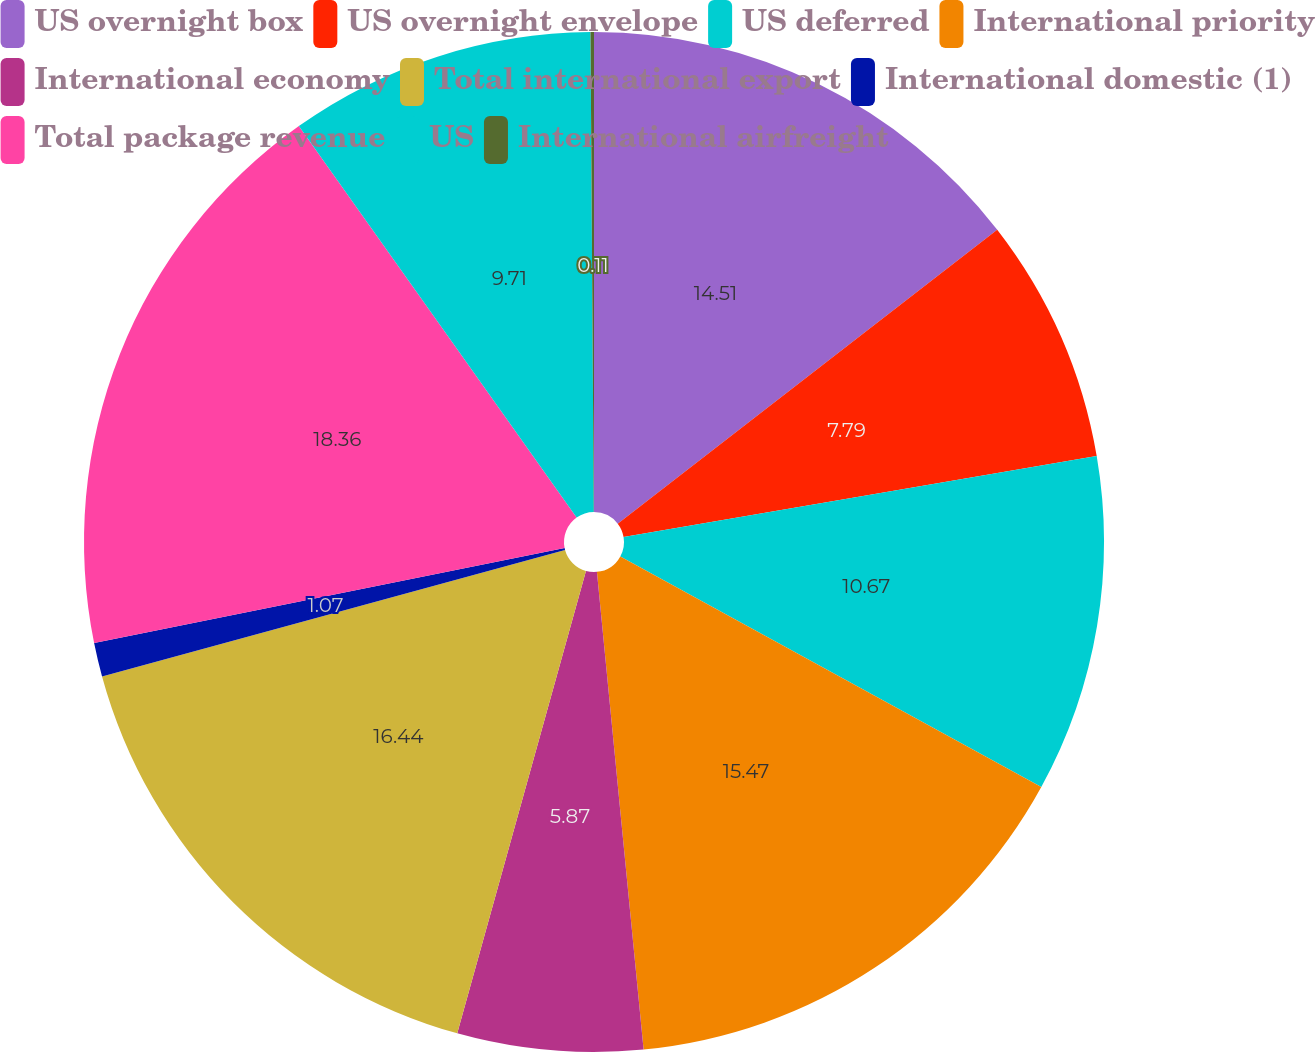Convert chart. <chart><loc_0><loc_0><loc_500><loc_500><pie_chart><fcel>US overnight box<fcel>US overnight envelope<fcel>US deferred<fcel>International priority<fcel>International economy<fcel>Total international export<fcel>International domestic (1)<fcel>Total package revenue<fcel>US<fcel>International airfreight<nl><fcel>14.51%<fcel>7.79%<fcel>10.67%<fcel>15.47%<fcel>5.87%<fcel>16.43%<fcel>1.07%<fcel>18.35%<fcel>9.71%<fcel>0.11%<nl></chart> 